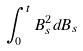<formula> <loc_0><loc_0><loc_500><loc_500>\int _ { 0 } ^ { t } B _ { s } ^ { 2 } d B _ { s }</formula> 